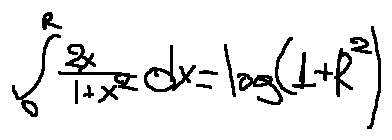<formula> <loc_0><loc_0><loc_500><loc_500>\int \lim i t s _ { 0 } ^ { R } \frac { 2 x } { 1 + x ^ { 2 } } d x = \log ( 1 + R ^ { 2 } )</formula> 